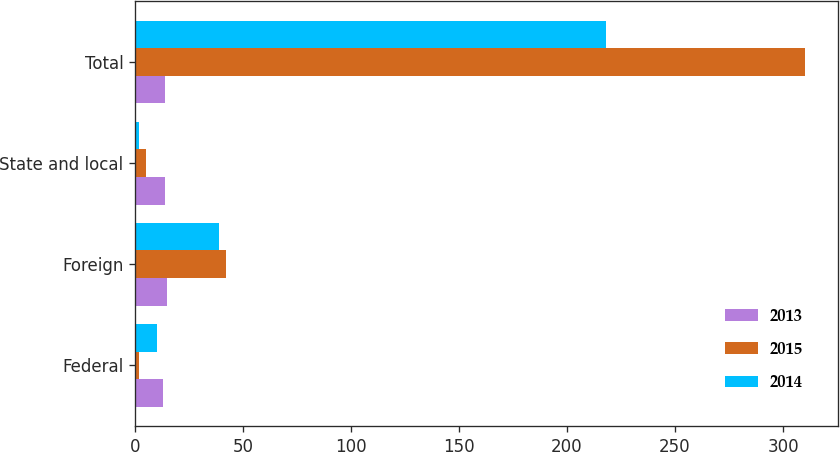Convert chart to OTSL. <chart><loc_0><loc_0><loc_500><loc_500><stacked_bar_chart><ecel><fcel>Federal<fcel>Foreign<fcel>State and local<fcel>Total<nl><fcel>2013<fcel>13<fcel>15<fcel>14<fcel>14<nl><fcel>2015<fcel>2<fcel>42<fcel>5<fcel>310<nl><fcel>2014<fcel>10<fcel>39<fcel>2<fcel>218<nl></chart> 